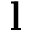<formula> <loc_0><loc_0><loc_500><loc_500>l</formula> 